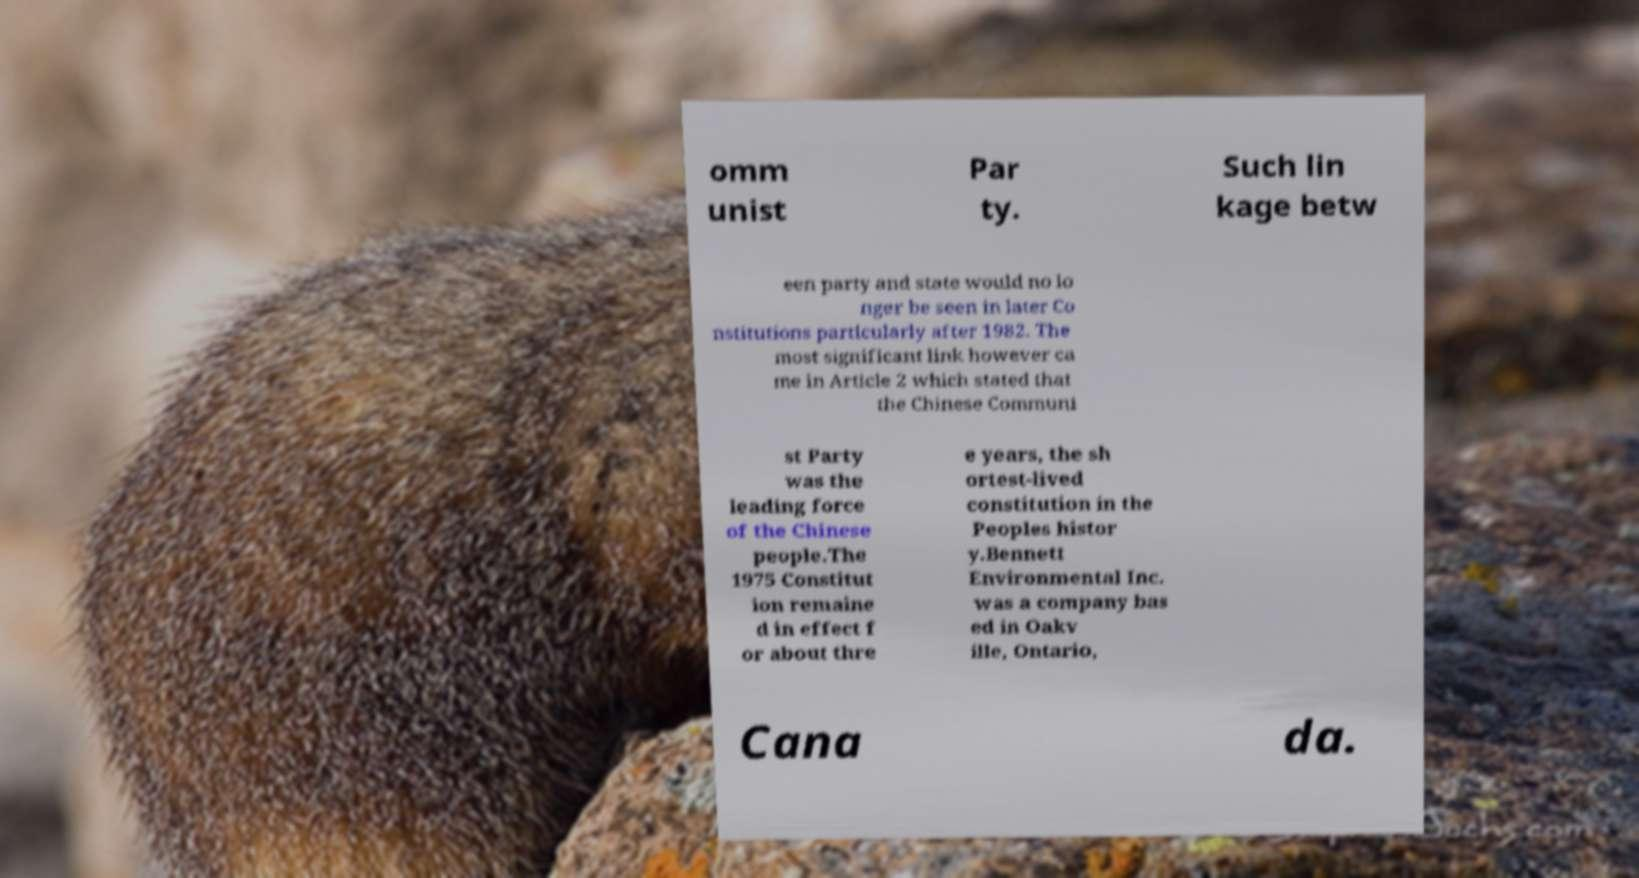Please identify and transcribe the text found in this image. omm unist Par ty. Such lin kage betw een party and state would no lo nger be seen in later Co nstitutions particularly after 1982. The most significant link however ca me in Article 2 which stated that the Chinese Communi st Party was the leading force of the Chinese people.The 1975 Constitut ion remaine d in effect f or about thre e years, the sh ortest-lived constitution in the Peoples histor y.Bennett Environmental Inc. was a company bas ed in Oakv ille, Ontario, Cana da. 